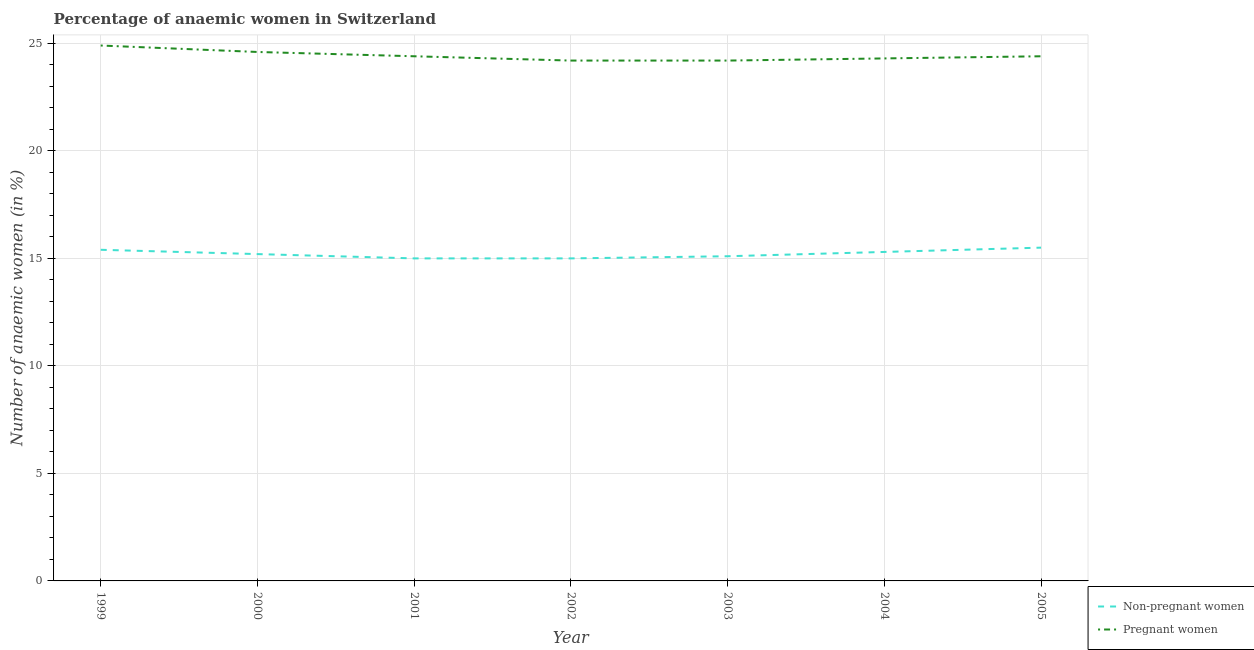How many different coloured lines are there?
Ensure brevity in your answer.  2. Does the line corresponding to percentage of pregnant anaemic women intersect with the line corresponding to percentage of non-pregnant anaemic women?
Provide a short and direct response. No. Is the number of lines equal to the number of legend labels?
Ensure brevity in your answer.  Yes. What is the percentage of pregnant anaemic women in 2005?
Give a very brief answer. 24.4. Across all years, what is the maximum percentage of pregnant anaemic women?
Ensure brevity in your answer.  24.9. Across all years, what is the minimum percentage of pregnant anaemic women?
Your response must be concise. 24.2. In which year was the percentage of pregnant anaemic women maximum?
Make the answer very short. 1999. In which year was the percentage of pregnant anaemic women minimum?
Offer a terse response. 2002. What is the total percentage of non-pregnant anaemic women in the graph?
Make the answer very short. 106.5. What is the difference between the percentage of non-pregnant anaemic women in 2001 and that in 2003?
Your answer should be very brief. -0.1. What is the difference between the percentage of non-pregnant anaemic women in 2002 and the percentage of pregnant anaemic women in 2001?
Your response must be concise. -9.4. What is the average percentage of pregnant anaemic women per year?
Offer a terse response. 24.43. In the year 2002, what is the difference between the percentage of pregnant anaemic women and percentage of non-pregnant anaemic women?
Make the answer very short. 9.2. In how many years, is the percentage of pregnant anaemic women greater than 9 %?
Offer a terse response. 7. What is the ratio of the percentage of non-pregnant anaemic women in 2000 to that in 2002?
Your response must be concise. 1.01. Is the percentage of pregnant anaemic women in 2004 less than that in 2005?
Offer a terse response. Yes. Is the difference between the percentage of non-pregnant anaemic women in 2001 and 2002 greater than the difference between the percentage of pregnant anaemic women in 2001 and 2002?
Offer a terse response. No. What is the difference between the highest and the second highest percentage of non-pregnant anaemic women?
Your answer should be very brief. 0.1. What is the difference between the highest and the lowest percentage of non-pregnant anaemic women?
Make the answer very short. 0.5. In how many years, is the percentage of non-pregnant anaemic women greater than the average percentage of non-pregnant anaemic women taken over all years?
Your answer should be compact. 3. Is the sum of the percentage of pregnant anaemic women in 2000 and 2004 greater than the maximum percentage of non-pregnant anaemic women across all years?
Your response must be concise. Yes. Does the percentage of non-pregnant anaemic women monotonically increase over the years?
Your answer should be very brief. No. How many lines are there?
Keep it short and to the point. 2. Does the graph contain grids?
Provide a short and direct response. Yes. Where does the legend appear in the graph?
Provide a succinct answer. Bottom right. How many legend labels are there?
Your answer should be compact. 2. How are the legend labels stacked?
Make the answer very short. Vertical. What is the title of the graph?
Provide a short and direct response. Percentage of anaemic women in Switzerland. Does "Lowest 20% of population" appear as one of the legend labels in the graph?
Your answer should be compact. No. What is the label or title of the X-axis?
Ensure brevity in your answer.  Year. What is the label or title of the Y-axis?
Ensure brevity in your answer.  Number of anaemic women (in %). What is the Number of anaemic women (in %) in Non-pregnant women in 1999?
Offer a terse response. 15.4. What is the Number of anaemic women (in %) in Pregnant women in 1999?
Your response must be concise. 24.9. What is the Number of anaemic women (in %) in Pregnant women in 2000?
Your answer should be compact. 24.6. What is the Number of anaemic women (in %) of Non-pregnant women in 2001?
Offer a terse response. 15. What is the Number of anaemic women (in %) in Pregnant women in 2001?
Give a very brief answer. 24.4. What is the Number of anaemic women (in %) of Non-pregnant women in 2002?
Ensure brevity in your answer.  15. What is the Number of anaemic women (in %) in Pregnant women in 2002?
Give a very brief answer. 24.2. What is the Number of anaemic women (in %) in Pregnant women in 2003?
Your answer should be compact. 24.2. What is the Number of anaemic women (in %) of Pregnant women in 2004?
Ensure brevity in your answer.  24.3. What is the Number of anaemic women (in %) in Non-pregnant women in 2005?
Offer a terse response. 15.5. What is the Number of anaemic women (in %) of Pregnant women in 2005?
Keep it short and to the point. 24.4. Across all years, what is the maximum Number of anaemic women (in %) of Pregnant women?
Your answer should be compact. 24.9. Across all years, what is the minimum Number of anaemic women (in %) in Non-pregnant women?
Offer a very short reply. 15. Across all years, what is the minimum Number of anaemic women (in %) of Pregnant women?
Offer a terse response. 24.2. What is the total Number of anaemic women (in %) in Non-pregnant women in the graph?
Offer a very short reply. 106.5. What is the total Number of anaemic women (in %) of Pregnant women in the graph?
Give a very brief answer. 171. What is the difference between the Number of anaemic women (in %) in Non-pregnant women in 1999 and that in 2000?
Keep it short and to the point. 0.2. What is the difference between the Number of anaemic women (in %) in Pregnant women in 1999 and that in 2000?
Your response must be concise. 0.3. What is the difference between the Number of anaemic women (in %) in Pregnant women in 1999 and that in 2001?
Make the answer very short. 0.5. What is the difference between the Number of anaemic women (in %) in Non-pregnant women in 1999 and that in 2002?
Make the answer very short. 0.4. What is the difference between the Number of anaemic women (in %) in Non-pregnant women in 1999 and that in 2003?
Offer a very short reply. 0.3. What is the difference between the Number of anaemic women (in %) of Non-pregnant women in 1999 and that in 2004?
Offer a terse response. 0.1. What is the difference between the Number of anaemic women (in %) of Pregnant women in 1999 and that in 2004?
Your response must be concise. 0.6. What is the difference between the Number of anaemic women (in %) in Non-pregnant women in 2000 and that in 2001?
Keep it short and to the point. 0.2. What is the difference between the Number of anaemic women (in %) of Pregnant women in 2000 and that in 2001?
Your answer should be compact. 0.2. What is the difference between the Number of anaemic women (in %) of Non-pregnant women in 2000 and that in 2004?
Your response must be concise. -0.1. What is the difference between the Number of anaemic women (in %) in Pregnant women in 2000 and that in 2005?
Your response must be concise. 0.2. What is the difference between the Number of anaemic women (in %) in Non-pregnant women in 2001 and that in 2002?
Offer a very short reply. 0. What is the difference between the Number of anaemic women (in %) in Pregnant women in 2001 and that in 2002?
Your answer should be compact. 0.2. What is the difference between the Number of anaemic women (in %) in Pregnant women in 2001 and that in 2003?
Provide a short and direct response. 0.2. What is the difference between the Number of anaemic women (in %) of Pregnant women in 2001 and that in 2004?
Your answer should be compact. 0.1. What is the difference between the Number of anaemic women (in %) of Non-pregnant women in 2002 and that in 2003?
Make the answer very short. -0.1. What is the difference between the Number of anaemic women (in %) in Non-pregnant women in 2002 and that in 2005?
Make the answer very short. -0.5. What is the difference between the Number of anaemic women (in %) of Non-pregnant women in 2003 and that in 2004?
Offer a very short reply. -0.2. What is the difference between the Number of anaemic women (in %) of Non-pregnant women in 2004 and that in 2005?
Your answer should be very brief. -0.2. What is the difference between the Number of anaemic women (in %) of Pregnant women in 2004 and that in 2005?
Offer a very short reply. -0.1. What is the difference between the Number of anaemic women (in %) in Non-pregnant women in 1999 and the Number of anaemic women (in %) in Pregnant women in 2000?
Keep it short and to the point. -9.2. What is the difference between the Number of anaemic women (in %) in Non-pregnant women in 1999 and the Number of anaemic women (in %) in Pregnant women in 2002?
Keep it short and to the point. -8.8. What is the difference between the Number of anaemic women (in %) in Non-pregnant women in 1999 and the Number of anaemic women (in %) in Pregnant women in 2003?
Provide a short and direct response. -8.8. What is the difference between the Number of anaemic women (in %) of Non-pregnant women in 1999 and the Number of anaemic women (in %) of Pregnant women in 2005?
Provide a short and direct response. -9. What is the difference between the Number of anaemic women (in %) in Non-pregnant women in 2000 and the Number of anaemic women (in %) in Pregnant women in 2001?
Provide a succinct answer. -9.2. What is the difference between the Number of anaemic women (in %) of Non-pregnant women in 2000 and the Number of anaemic women (in %) of Pregnant women in 2004?
Make the answer very short. -9.1. What is the difference between the Number of anaemic women (in %) in Non-pregnant women in 2001 and the Number of anaemic women (in %) in Pregnant women in 2003?
Provide a short and direct response. -9.2. What is the difference between the Number of anaemic women (in %) in Non-pregnant women in 2001 and the Number of anaemic women (in %) in Pregnant women in 2004?
Your response must be concise. -9.3. What is the difference between the Number of anaemic women (in %) of Non-pregnant women in 2001 and the Number of anaemic women (in %) of Pregnant women in 2005?
Ensure brevity in your answer.  -9.4. What is the difference between the Number of anaemic women (in %) in Non-pregnant women in 2002 and the Number of anaemic women (in %) in Pregnant women in 2003?
Your answer should be very brief. -9.2. What is the difference between the Number of anaemic women (in %) in Non-pregnant women in 2002 and the Number of anaemic women (in %) in Pregnant women in 2004?
Provide a short and direct response. -9.3. What is the difference between the Number of anaemic women (in %) in Non-pregnant women in 2003 and the Number of anaemic women (in %) in Pregnant women in 2004?
Provide a short and direct response. -9.2. What is the difference between the Number of anaemic women (in %) of Non-pregnant women in 2004 and the Number of anaemic women (in %) of Pregnant women in 2005?
Ensure brevity in your answer.  -9.1. What is the average Number of anaemic women (in %) of Non-pregnant women per year?
Your answer should be very brief. 15.21. What is the average Number of anaemic women (in %) of Pregnant women per year?
Provide a short and direct response. 24.43. In the year 2001, what is the difference between the Number of anaemic women (in %) of Non-pregnant women and Number of anaemic women (in %) of Pregnant women?
Your answer should be compact. -9.4. In the year 2002, what is the difference between the Number of anaemic women (in %) in Non-pregnant women and Number of anaemic women (in %) in Pregnant women?
Your response must be concise. -9.2. What is the ratio of the Number of anaemic women (in %) in Non-pregnant women in 1999 to that in 2000?
Ensure brevity in your answer.  1.01. What is the ratio of the Number of anaemic women (in %) of Pregnant women in 1999 to that in 2000?
Offer a terse response. 1.01. What is the ratio of the Number of anaemic women (in %) in Non-pregnant women in 1999 to that in 2001?
Keep it short and to the point. 1.03. What is the ratio of the Number of anaemic women (in %) in Pregnant women in 1999 to that in 2001?
Offer a terse response. 1.02. What is the ratio of the Number of anaemic women (in %) of Non-pregnant women in 1999 to that in 2002?
Your answer should be compact. 1.03. What is the ratio of the Number of anaemic women (in %) in Pregnant women in 1999 to that in 2002?
Your response must be concise. 1.03. What is the ratio of the Number of anaemic women (in %) in Non-pregnant women in 1999 to that in 2003?
Offer a terse response. 1.02. What is the ratio of the Number of anaemic women (in %) of Pregnant women in 1999 to that in 2003?
Your response must be concise. 1.03. What is the ratio of the Number of anaemic women (in %) of Pregnant women in 1999 to that in 2004?
Keep it short and to the point. 1.02. What is the ratio of the Number of anaemic women (in %) in Pregnant women in 1999 to that in 2005?
Give a very brief answer. 1.02. What is the ratio of the Number of anaemic women (in %) in Non-pregnant women in 2000 to that in 2001?
Give a very brief answer. 1.01. What is the ratio of the Number of anaemic women (in %) of Pregnant women in 2000 to that in 2001?
Offer a terse response. 1.01. What is the ratio of the Number of anaemic women (in %) of Non-pregnant women in 2000 to that in 2002?
Your response must be concise. 1.01. What is the ratio of the Number of anaemic women (in %) of Pregnant women in 2000 to that in 2002?
Your answer should be compact. 1.02. What is the ratio of the Number of anaemic women (in %) of Non-pregnant women in 2000 to that in 2003?
Offer a very short reply. 1.01. What is the ratio of the Number of anaemic women (in %) in Pregnant women in 2000 to that in 2003?
Give a very brief answer. 1.02. What is the ratio of the Number of anaemic women (in %) of Pregnant women in 2000 to that in 2004?
Make the answer very short. 1.01. What is the ratio of the Number of anaemic women (in %) of Non-pregnant women in 2000 to that in 2005?
Your answer should be very brief. 0.98. What is the ratio of the Number of anaemic women (in %) in Pregnant women in 2000 to that in 2005?
Make the answer very short. 1.01. What is the ratio of the Number of anaemic women (in %) of Pregnant women in 2001 to that in 2002?
Ensure brevity in your answer.  1.01. What is the ratio of the Number of anaemic women (in %) in Non-pregnant women in 2001 to that in 2003?
Your answer should be compact. 0.99. What is the ratio of the Number of anaemic women (in %) of Pregnant women in 2001 to that in 2003?
Provide a short and direct response. 1.01. What is the ratio of the Number of anaemic women (in %) in Non-pregnant women in 2001 to that in 2004?
Offer a very short reply. 0.98. What is the ratio of the Number of anaemic women (in %) of Pregnant women in 2001 to that in 2004?
Ensure brevity in your answer.  1. What is the ratio of the Number of anaemic women (in %) of Non-pregnant women in 2001 to that in 2005?
Your answer should be compact. 0.97. What is the ratio of the Number of anaemic women (in %) of Pregnant women in 2001 to that in 2005?
Provide a short and direct response. 1. What is the ratio of the Number of anaemic women (in %) in Non-pregnant women in 2002 to that in 2003?
Make the answer very short. 0.99. What is the ratio of the Number of anaemic women (in %) of Non-pregnant women in 2002 to that in 2004?
Offer a very short reply. 0.98. What is the ratio of the Number of anaemic women (in %) in Pregnant women in 2002 to that in 2005?
Provide a short and direct response. 0.99. What is the ratio of the Number of anaemic women (in %) of Non-pregnant women in 2003 to that in 2004?
Ensure brevity in your answer.  0.99. What is the ratio of the Number of anaemic women (in %) of Pregnant women in 2003 to that in 2004?
Offer a terse response. 1. What is the ratio of the Number of anaemic women (in %) in Non-pregnant women in 2003 to that in 2005?
Your answer should be very brief. 0.97. What is the ratio of the Number of anaemic women (in %) of Pregnant women in 2003 to that in 2005?
Your answer should be compact. 0.99. What is the ratio of the Number of anaemic women (in %) of Non-pregnant women in 2004 to that in 2005?
Your response must be concise. 0.99. What is the difference between the highest and the second highest Number of anaemic women (in %) in Pregnant women?
Offer a terse response. 0.3. What is the difference between the highest and the lowest Number of anaemic women (in %) of Pregnant women?
Provide a succinct answer. 0.7. 